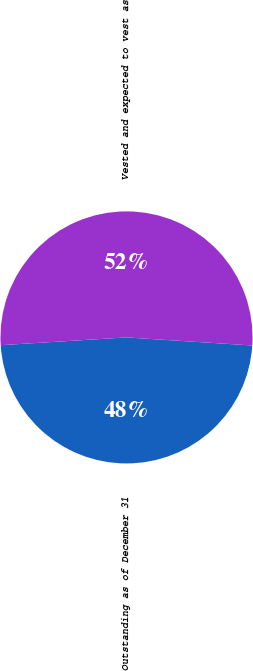<chart> <loc_0><loc_0><loc_500><loc_500><pie_chart><fcel>Outstanding as of December 31<fcel>Vested and expected to vest as<nl><fcel>48.0%<fcel>52.0%<nl></chart> 